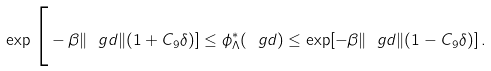<formula> <loc_0><loc_0><loc_500><loc_500>\exp \Big [ - \beta \| \ g d \| ( 1 + C _ { 9 } \delta ) ] \leq \phi ^ { * } _ { \Lambda } ( \ g d ) \leq \exp [ - \beta \| \ g d \| ( 1 - C _ { 9 } \delta ) ] \, .</formula> 